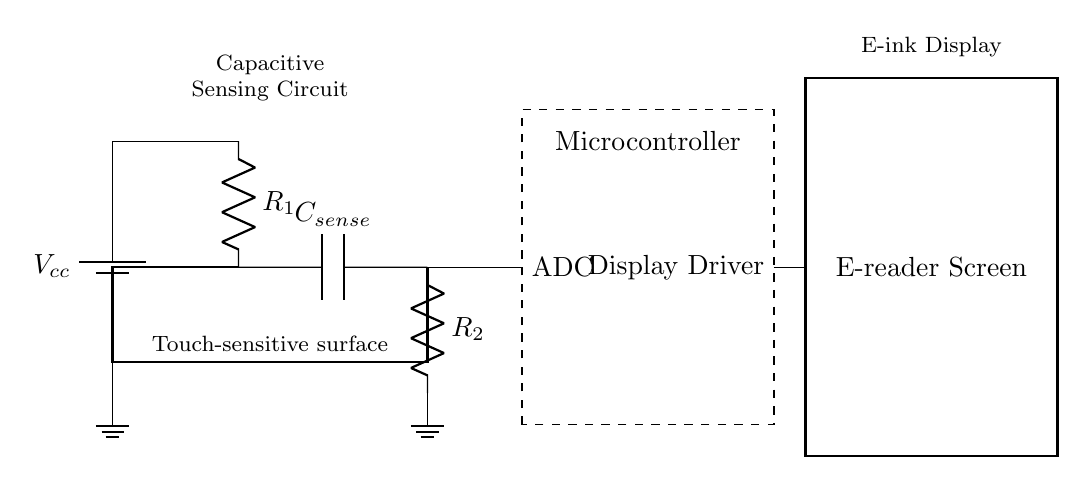What type of circuit is depicted? The circuit is a capacitive sensing circuit designed for touch-sensitive functionality in a mobile device. It uses capacitors to detect changes in touch and translates them into signals processed by the microcontroller.
Answer: capacitive sensing circuit What is the value of R1? The circuit diagram does not specify the numerical value of R1, indicating it may be variable or dependent on design specifications.
Answer: unspecified What component connects to the e-reader screen? The display driver connects to the e-reader screen, enabling it to display information based on input from the microcontroller.
Answer: display driver What is the role of the microcontroller in this circuit? The microcontroller processes input from the touch-sensitive circuit and sends signals to the display driver, managing how the e-reader screen responds to touch commands.
Answer: processing input How does touch sensing occur in this circuit? Touch sensing occurs through the interaction between the capacitive sensor and the changes in capacitance caused by a finger's proximity, detected by the ADC in the microcontroller.
Answer: through capacitance change What is the significance of the capacitor Csense? The capacitor Csense is critical for capacitive touch sensing as it detects the responsiveness of the touch surface by measuring changes in capacitance. This allows the circuit to interpret touch interactions.
Answer: detects capacitance changes What is the connection between R2 and ground? R2 is connected to ground, providing a reference point for the circuit and allowing for the proper functioning of the capacitive sensing mechanism by influencing the charge and discharge of Csense.
Answer: reference point 